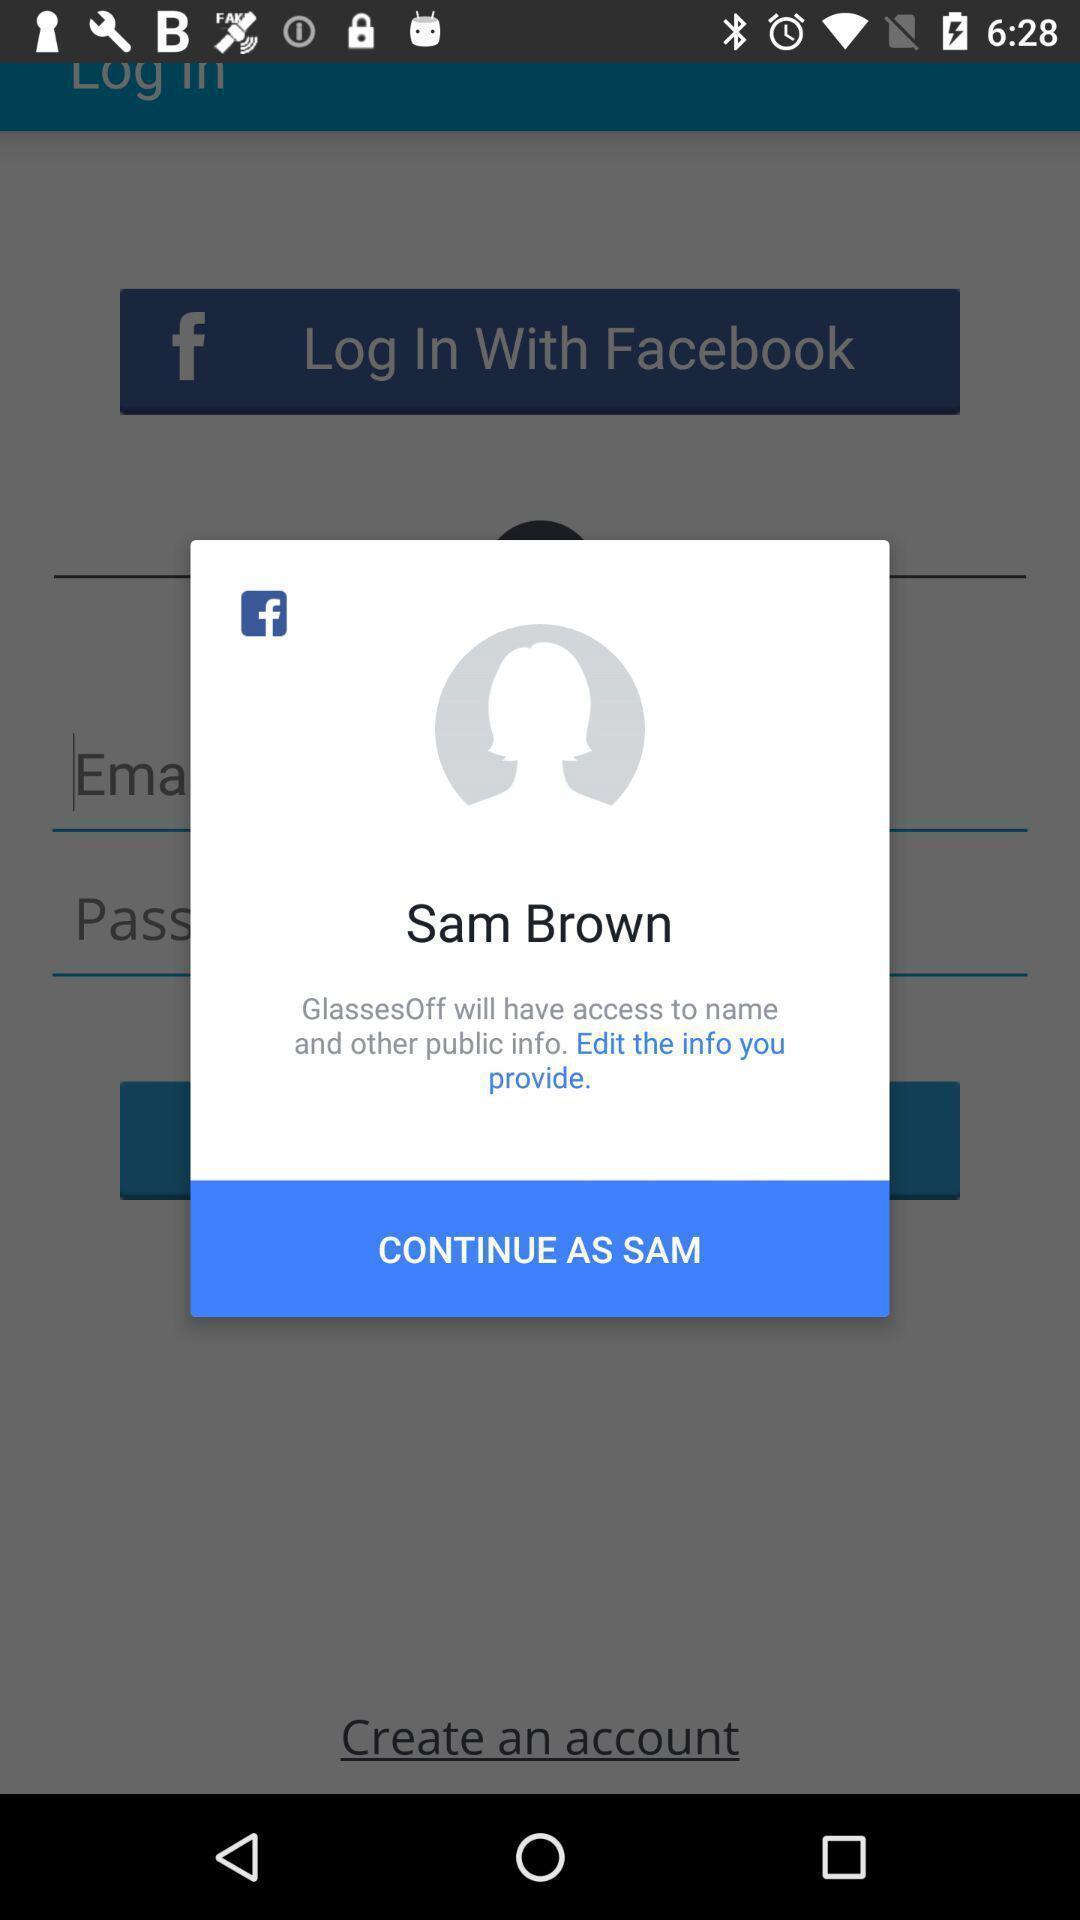What details can you identify in this image? Pop up showing in social networking application. 